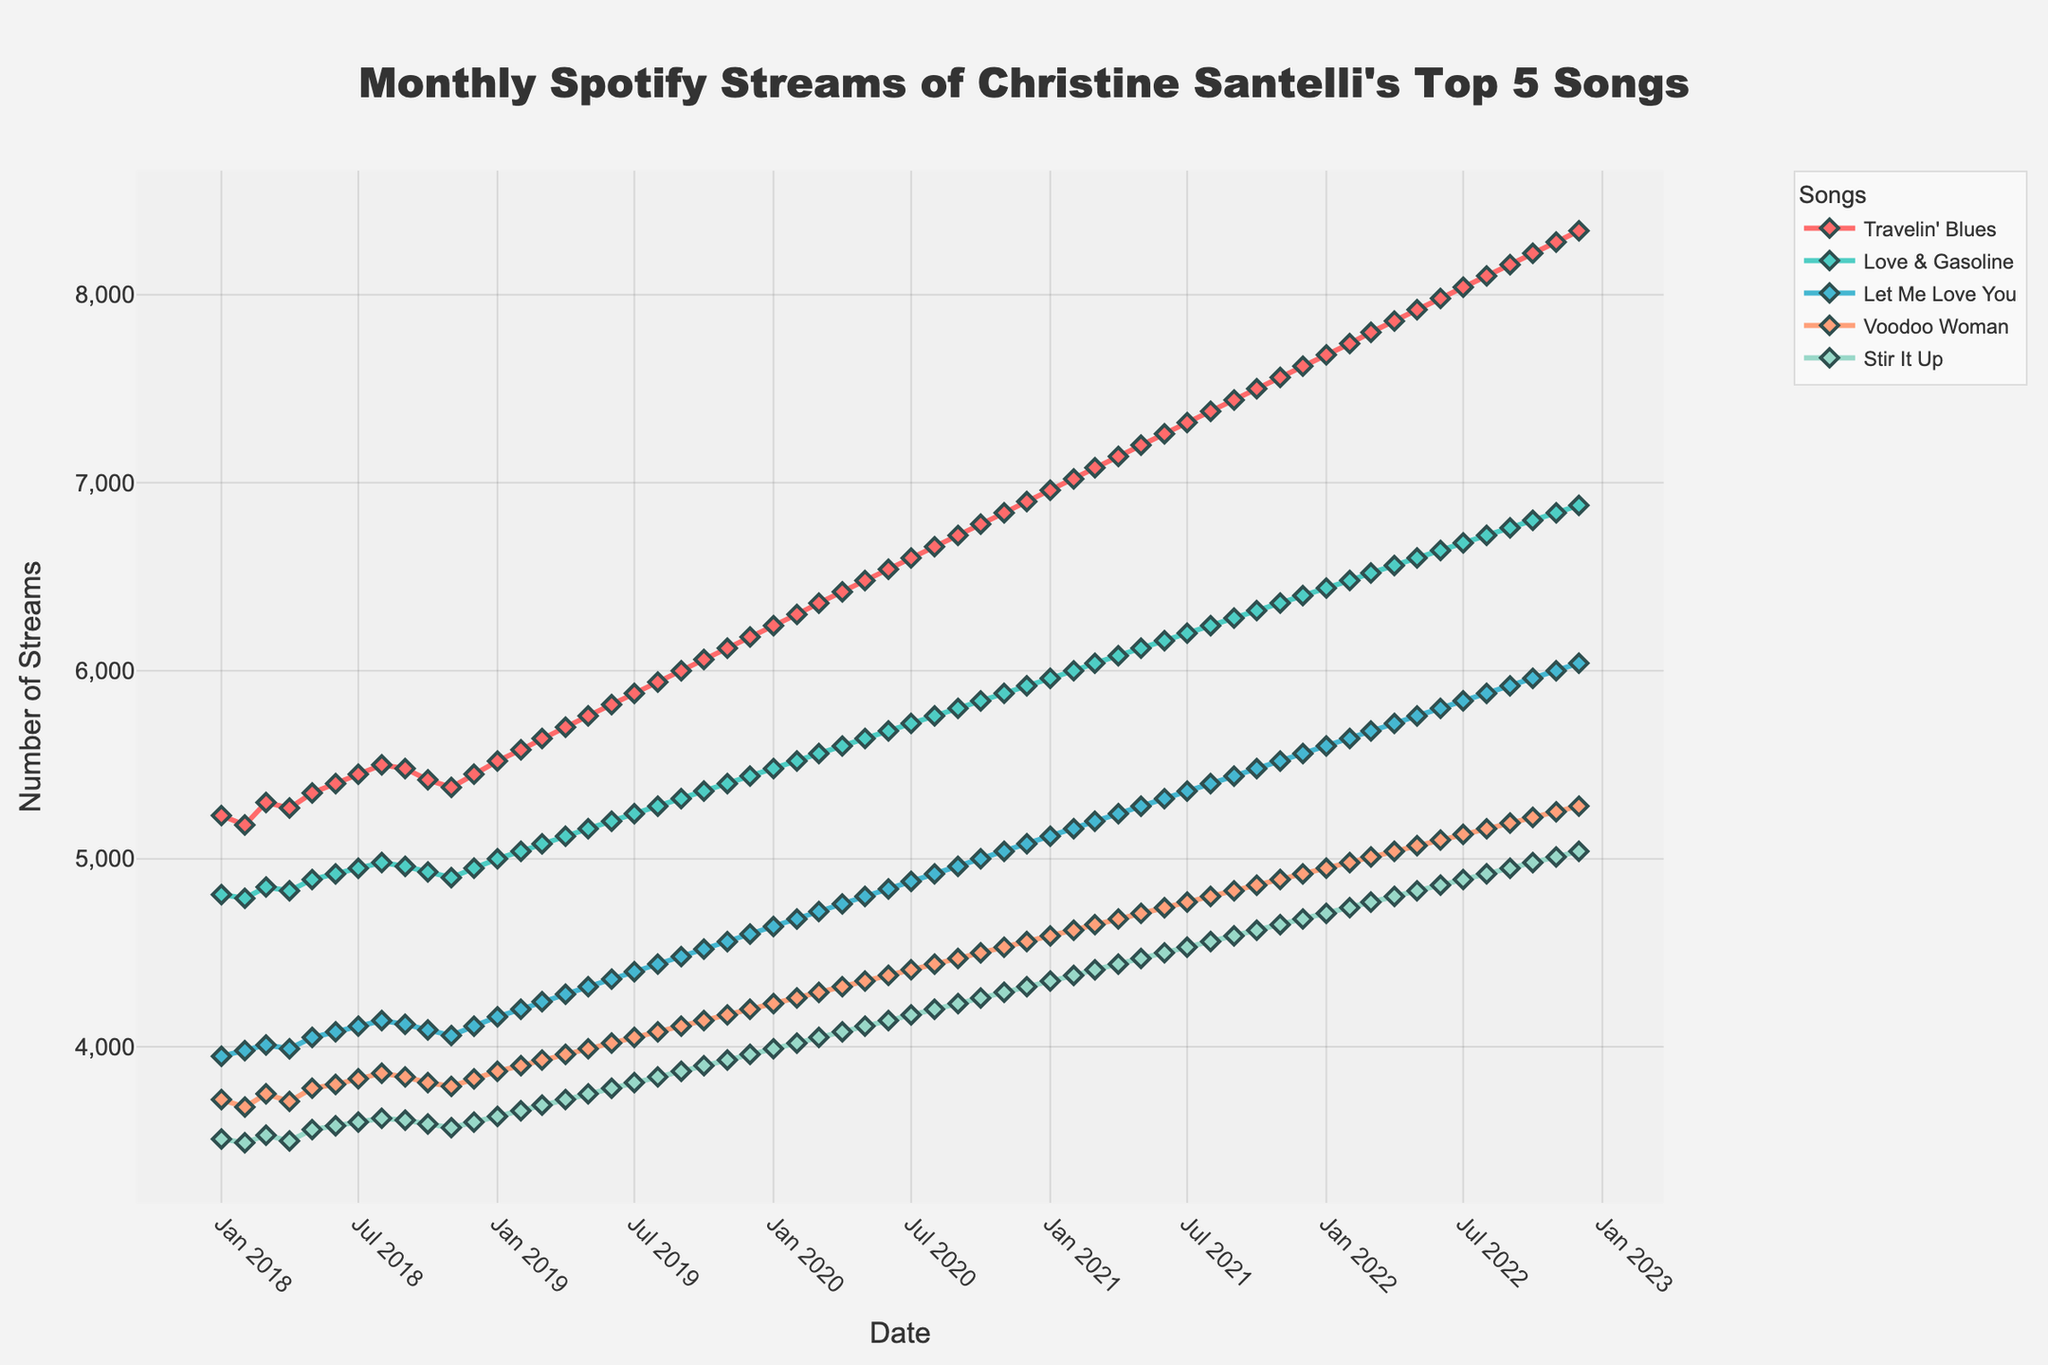What is the overall trend in the number of streams for 'Travelin' Blues' over the 5-year period? By viewing the plotted line for 'Travelin' Blues,' we can see an upward trend from a starting point of 5230 in January 2018 to 8340 in December 2022. All the intermediate points show a general increase without significant dips.
Answer: Upward trend Which song had the highest number of streams in December 2022? By looking at the points on the far right of the chart for each song, we can see 'Travelin' Blues' has the highest number of streams at 8340 in December 2022 compared to the other songs.
Answer: 'Travelin' Blues' How does the number of streams in December 2022 for 'Let Me Love You' compare with its number of streams in January 2018? 'Let Me Love You' had 6040 streams in December 2022 and 3950 streams in January 2018. Subtracting these, 6040 - 3950, the number of streams increased by 2090.
Answer: Increased by 2090 Between 'Voodoo Woman' and 'Stir It Up,' which song had more streams in September 2020? By comparing the points on the chart for September 2020, 'Voodoo Woman' had 4470 streams, while 'Stir It Up' had 4230 streams. Thus, 'Voodoo Woman' had more streams.
Answer: 'Voodoo Woman' What is the average number of streams for 'Love & Gasoline' across all months in 2019? To find the average, take the monthly streams for 'Love & Gasoline' in 2019: 5000, 5040, 5080, 5120, 5160, 5200, 5240, 5280, 5320, 5360, 5400, 5440. Sum these up to get 62680, then divide by 12: 62680/12 = 5223.33 (rounded to two decimal places).
Answer: 5223.33 Which song consistently showed the least number of streams over the years and by how much did it increase from January 2018 to December 2022? The song with the consistently least number of streams as evident from the lowest points across time is 'Stir It Up.' The number of streams in January 2018 was 3510, and in December 2022, it increased to 5040. The increase is 5040 - 3510 = 1530.
Answer: 'Stir It Up', increased by 1530 What is the difference in streams between 'Love & Gasoline' and 'Voodoo Woman' in March 2020? 'Love & Gasoline' had 5560 streams, and 'Voodoo Woman' had 4290 streams in March 2020. The difference is calculated as 5560 - 4290 = 1270.
Answer: 1270 Identify the month and year where 'Let Me Love You' hit 5000 streams for the first time. By examining the line for 'Let Me Love You,' it crossed the 5000 streams mark in October 2020 when it reached 5000 streams.
Answer: October 2020 